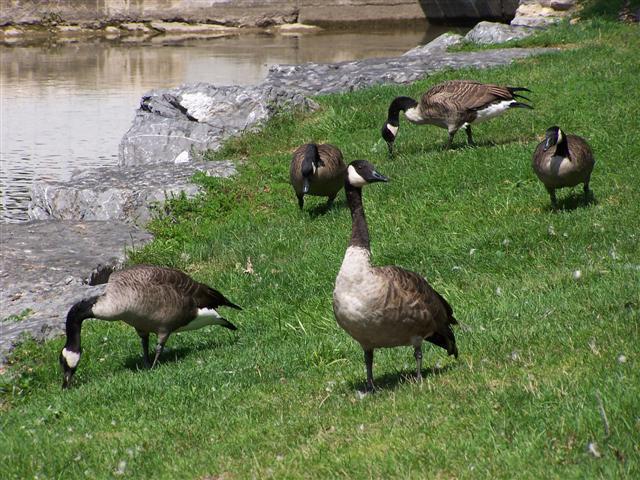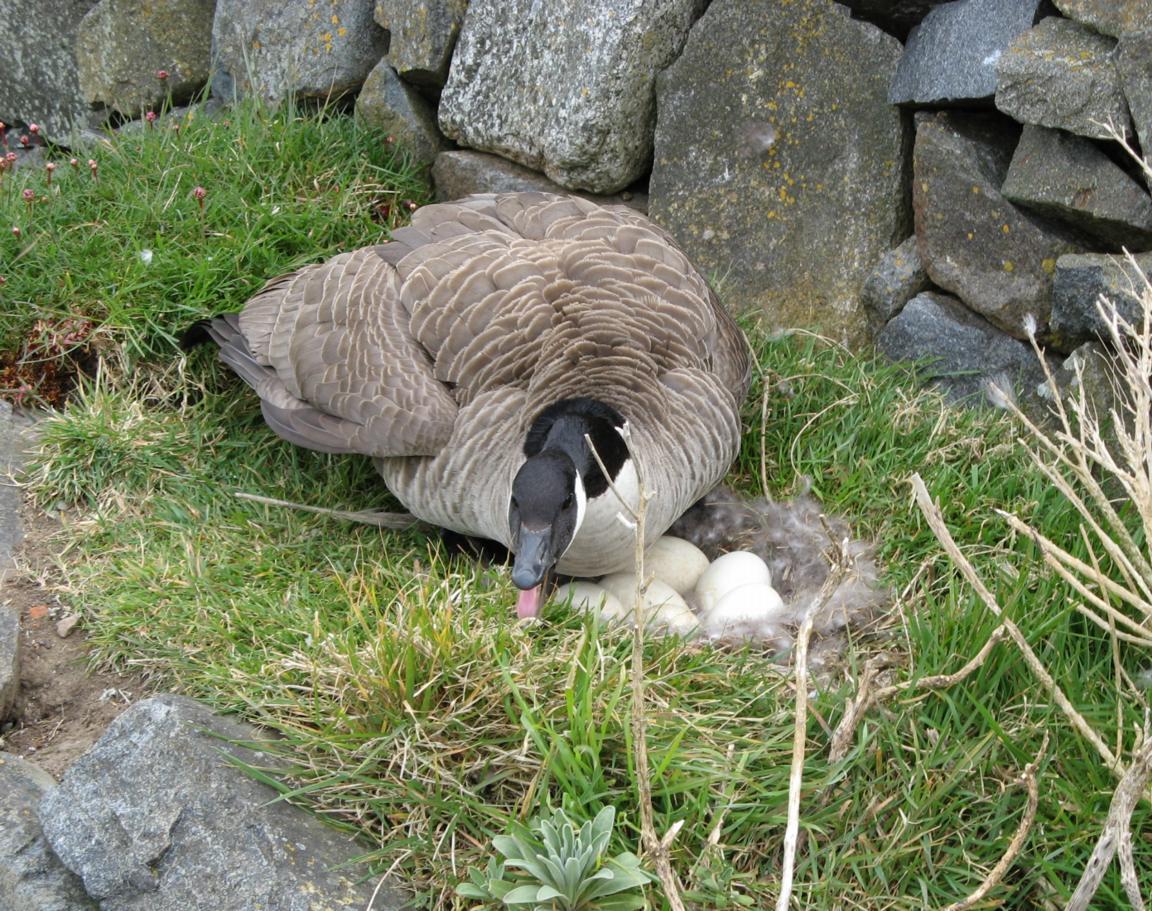The first image is the image on the left, the second image is the image on the right. Considering the images on both sides, is "In one of the image the geese are in the water." valid? Answer yes or no. No. 